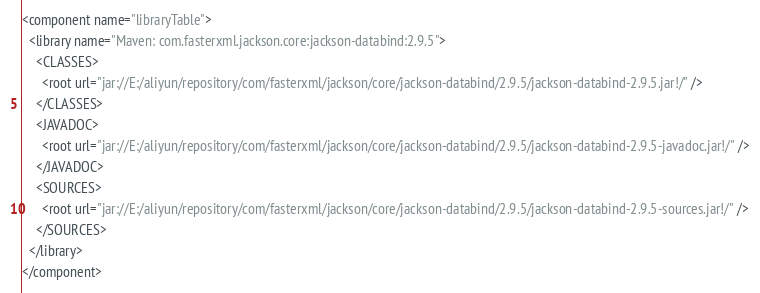<code> <loc_0><loc_0><loc_500><loc_500><_XML_><component name="libraryTable">
  <library name="Maven: com.fasterxml.jackson.core:jackson-databind:2.9.5">
    <CLASSES>
      <root url="jar://E:/aliyun/repository/com/fasterxml/jackson/core/jackson-databind/2.9.5/jackson-databind-2.9.5.jar!/" />
    </CLASSES>
    <JAVADOC>
      <root url="jar://E:/aliyun/repository/com/fasterxml/jackson/core/jackson-databind/2.9.5/jackson-databind-2.9.5-javadoc.jar!/" />
    </JAVADOC>
    <SOURCES>
      <root url="jar://E:/aliyun/repository/com/fasterxml/jackson/core/jackson-databind/2.9.5/jackson-databind-2.9.5-sources.jar!/" />
    </SOURCES>
  </library>
</component></code> 